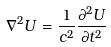Convert formula to latex. <formula><loc_0><loc_0><loc_500><loc_500>\nabla ^ { 2 } U = \frac { 1 } { c ^ { 2 } } \frac { \partial ^ { 2 } U } { \partial t ^ { 2 } }</formula> 